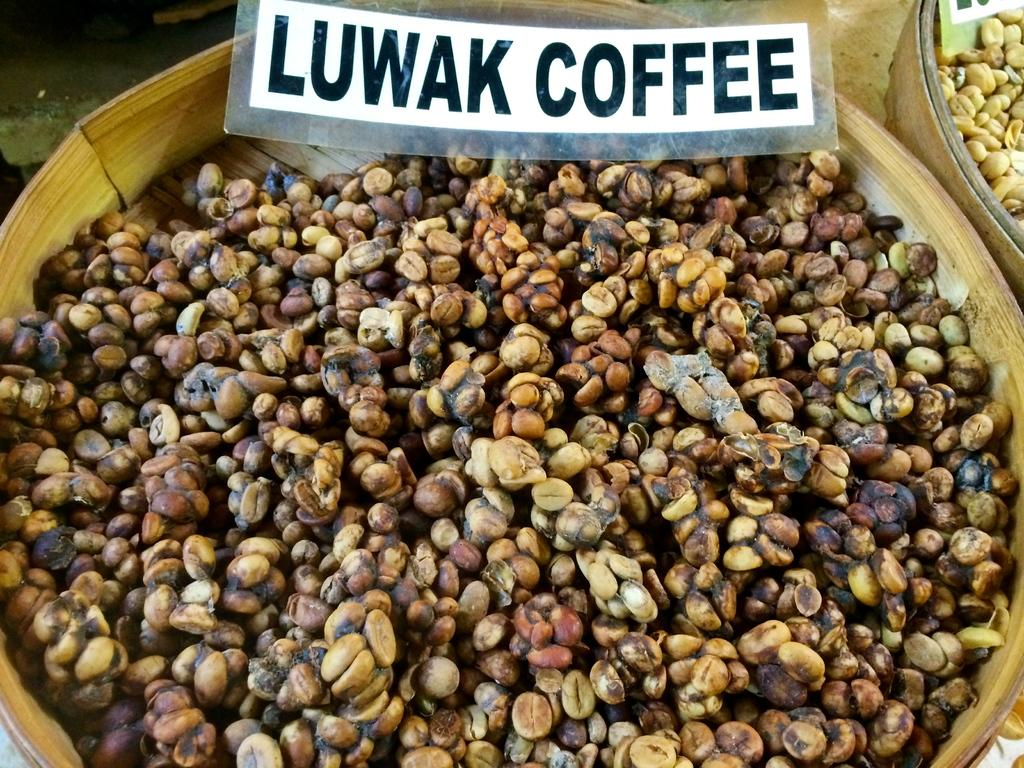How many baskets are present in the image? There are two baskets in the image. What are the baskets containing? The baskets contain beans. What can be seen at the top of the image? There are boards visible at the top of the image. What is written on the boards? Words are written on the boards. What type of furniture is being discovered in the image? There is no furniture being discovered in the image; it features two baskets containing beans and boards with words written on them. What nation is depicted in the image? The image does not depict a specific nation; it focuses on baskets, beans, boards, and words. 